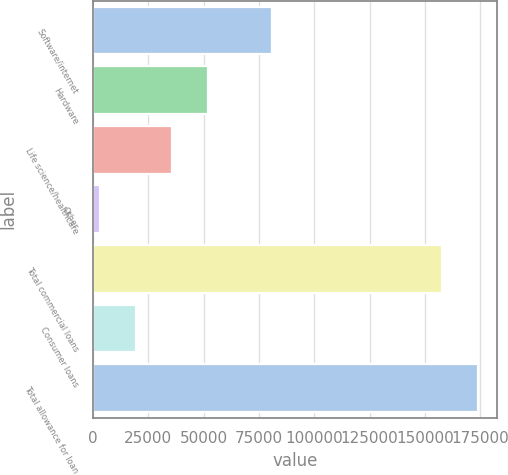Convert chart to OTSL. <chart><loc_0><loc_0><loc_500><loc_500><bar_chart><fcel>Software/internet<fcel>Hardware<fcel>Life science/healthcare<fcel>Other<fcel>Total commercial loans<fcel>Consumer loans<fcel>Total allowance for loan<nl><fcel>80981<fcel>51884.8<fcel>35674.2<fcel>3253<fcel>157772<fcel>19463.6<fcel>173983<nl></chart> 